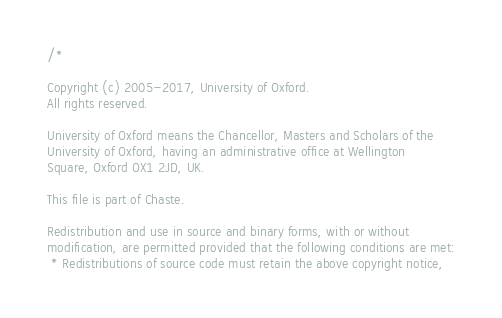Convert code to text. <code><loc_0><loc_0><loc_500><loc_500><_C++_>/*

Copyright (c) 2005-2017, University of Oxford.
All rights reserved.

University of Oxford means the Chancellor, Masters and Scholars of the
University of Oxford, having an administrative office at Wellington
Square, Oxford OX1 2JD, UK.

This file is part of Chaste.

Redistribution and use in source and binary forms, with or without
modification, are permitted provided that the following conditions are met:
 * Redistributions of source code must retain the above copyright notice,</code> 